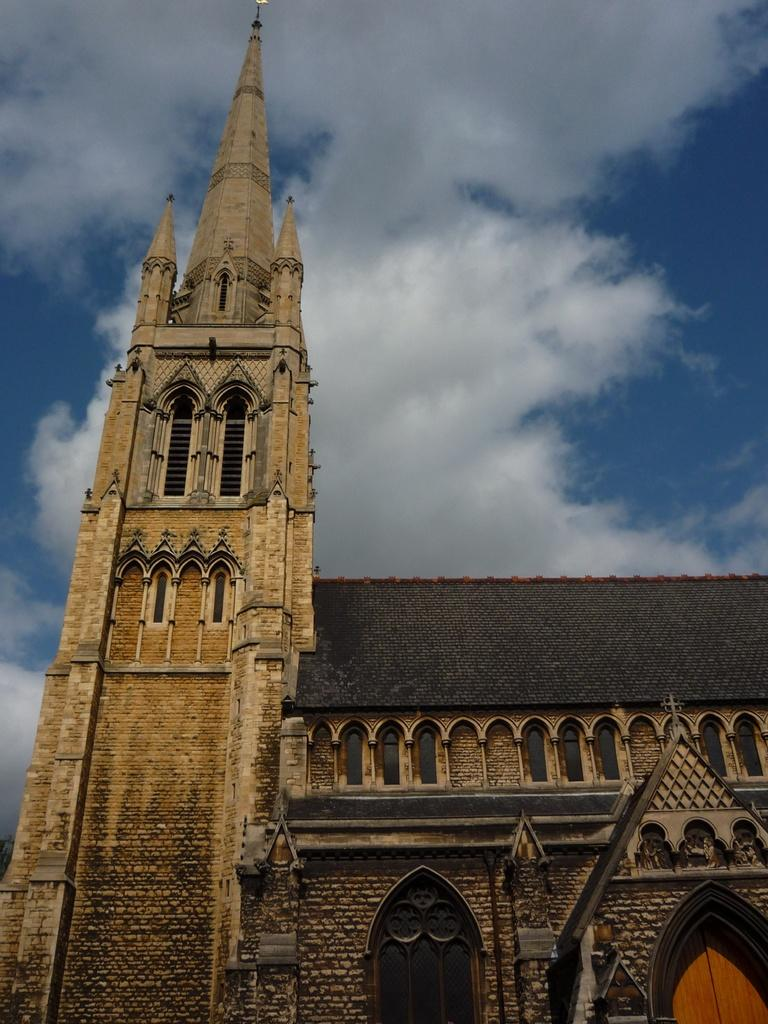What type of structure is present in the image? There is a building in the image. How would you describe the sky in the image? The sky is blue and cloudy in the image. What grade level is the building in the image designed for? There is no information about the grade level or purpose of the building in the image. How many cats can be seen on the roof of the building in the image? There are no cats present in the image. 